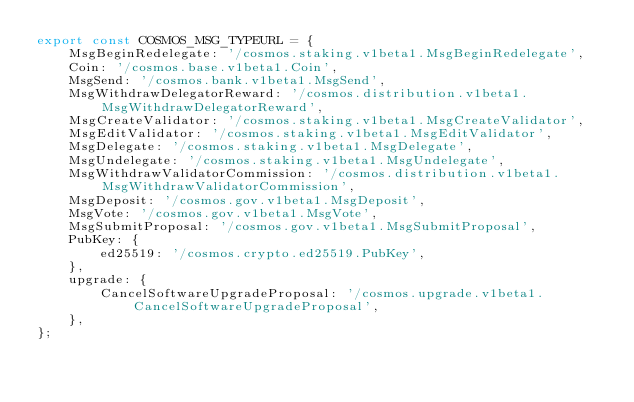<code> <loc_0><loc_0><loc_500><loc_500><_TypeScript_>export const COSMOS_MSG_TYPEURL = {
    MsgBeginRedelegate: '/cosmos.staking.v1beta1.MsgBeginRedelegate',
    Coin: '/cosmos.base.v1beta1.Coin',
    MsgSend: '/cosmos.bank.v1beta1.MsgSend',
    MsgWithdrawDelegatorReward: '/cosmos.distribution.v1beta1.MsgWithdrawDelegatorReward',
    MsgCreateValidator: '/cosmos.staking.v1beta1.MsgCreateValidator',
    MsgEditValidator: '/cosmos.staking.v1beta1.MsgEditValidator',
    MsgDelegate: '/cosmos.staking.v1beta1.MsgDelegate',
    MsgUndelegate: '/cosmos.staking.v1beta1.MsgUndelegate',
    MsgWithdrawValidatorCommission: '/cosmos.distribution.v1beta1.MsgWithdrawValidatorCommission',
    MsgDeposit: '/cosmos.gov.v1beta1.MsgDeposit',
    MsgVote: '/cosmos.gov.v1beta1.MsgVote',
    MsgSubmitProposal: '/cosmos.gov.v1beta1.MsgSubmitProposal',
    PubKey: {
        ed25519: '/cosmos.crypto.ed25519.PubKey',
    },
    upgrade: {
        CancelSoftwareUpgradeProposal: '/cosmos.upgrade.v1beta1.CancelSoftwareUpgradeProposal',
    },
};
</code> 